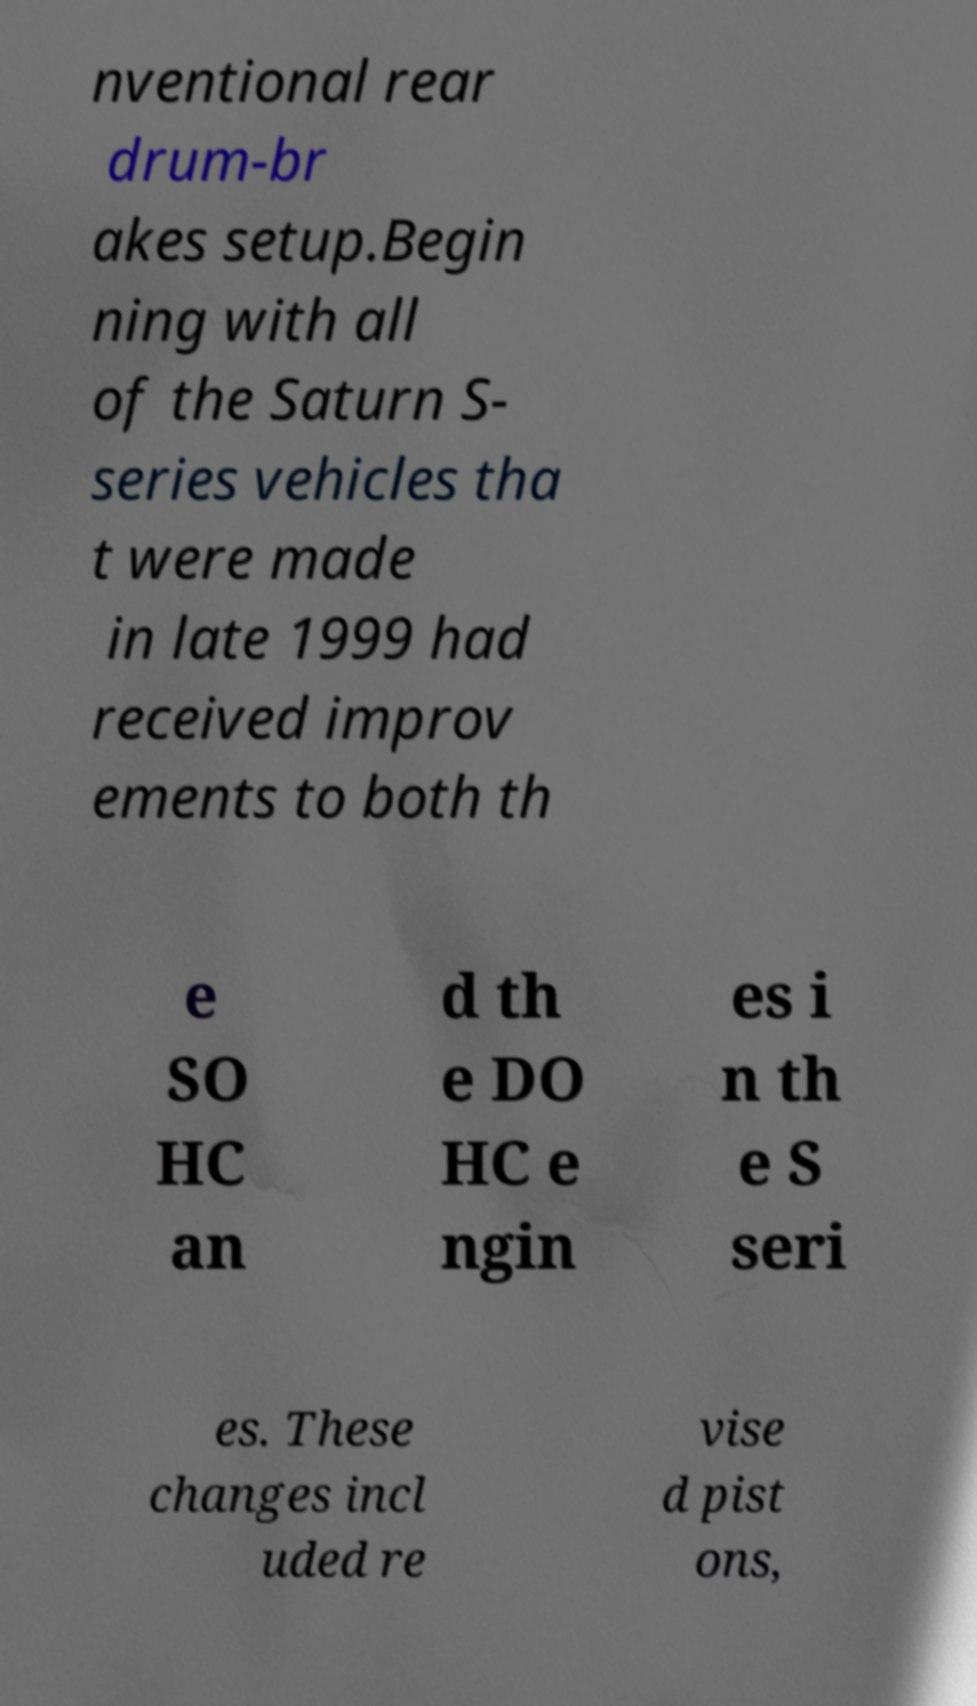Please identify and transcribe the text found in this image. nventional rear drum-br akes setup.Begin ning with all of the Saturn S- series vehicles tha t were made in late 1999 had received improv ements to both th e SO HC an d th e DO HC e ngin es i n th e S seri es. These changes incl uded re vise d pist ons, 